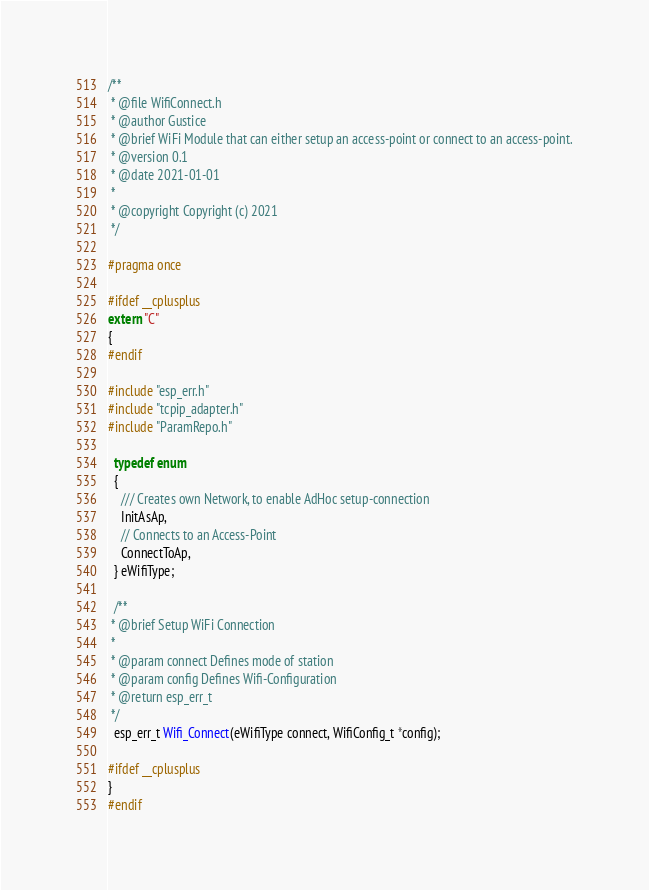Convert code to text. <code><loc_0><loc_0><loc_500><loc_500><_C_>/**
 * @file WifiConnect.h
 * @author Gustice
 * @brief WiFi Module that can either setup an access-point or connect to an access-point.
 * @version 0.1
 * @date 2021-01-01
 * 
 * @copyright Copyright (c) 2021
 */

#pragma once

#ifdef __cplusplus
extern "C"
{
#endif

#include "esp_err.h"
#include "tcpip_adapter.h"
#include "ParamRepo.h"

  typedef enum
  {
    /// Creates own Network, to enable AdHoc setup-connection
    InitAsAp,
    // Connects to an Access-Point
    ConnectToAp,
  } eWifiType;

  /**
 * @brief Setup WiFi Connection
 * 
 * @param connect Defines mode of station
 * @param config Defines Wifi-Configuration
 * @return esp_err_t 
 */
  esp_err_t Wifi_Connect(eWifiType connect, WifiConfig_t *config);

#ifdef __cplusplus
}
#endif
</code> 